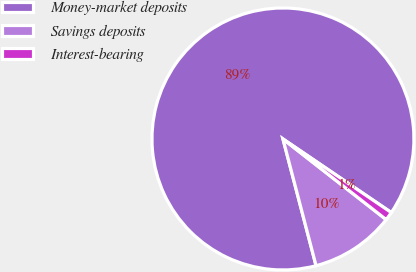Convert chart to OTSL. <chart><loc_0><loc_0><loc_500><loc_500><pie_chart><fcel>Money-market deposits<fcel>Savings deposits<fcel>Interest-bearing<nl><fcel>88.57%<fcel>10.38%<fcel>1.06%<nl></chart> 